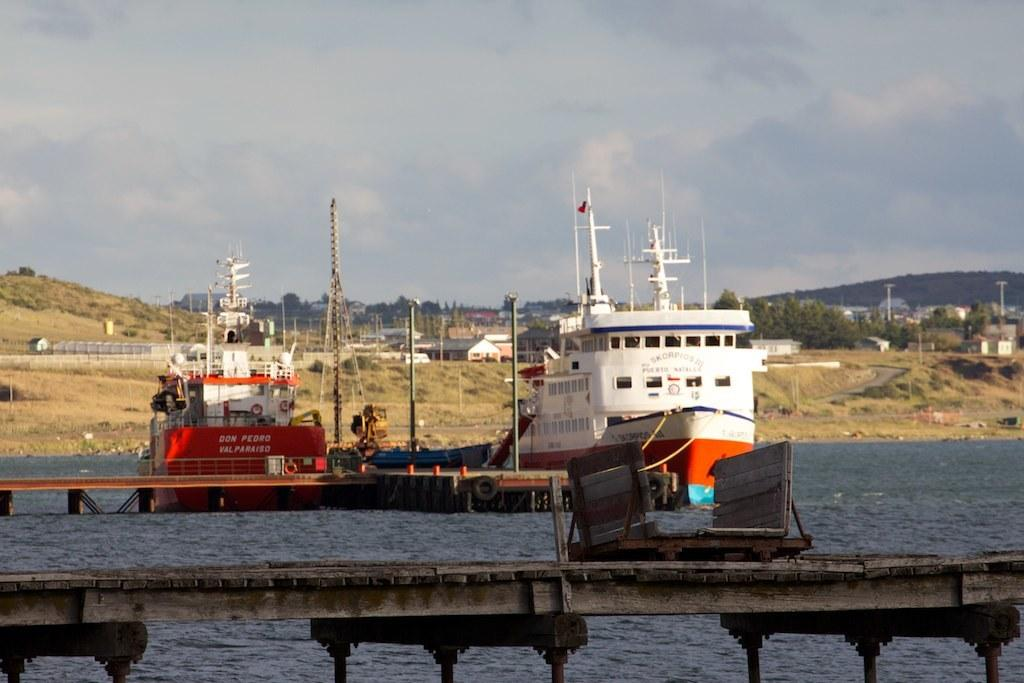What type of location is depicted in the image? There is a sea port in the image. How many ships can be seen in the sea port? There are two ships in the sea port. What structures are located behind the ships? There are sheds behind the ships. What can be seen in the distance in the image? There are mountains in the background, and the sky is cloudy. Where is the store located in the image? There is no store present in the image; it depicts a sea port with ships, sheds, mountains, and a cloudy sky. What type of cattle can be seen grazing near the ships? There are no cattle present in the image; it only features ships, sheds, mountains, and a cloudy sky. 